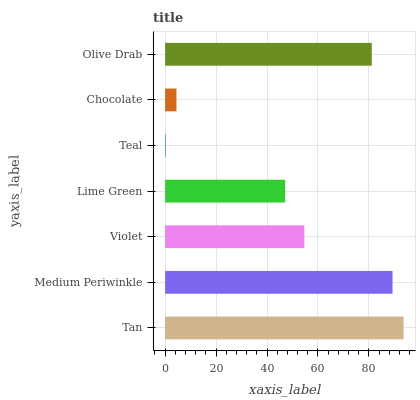Is Teal the minimum?
Answer yes or no. Yes. Is Tan the maximum?
Answer yes or no. Yes. Is Medium Periwinkle the minimum?
Answer yes or no. No. Is Medium Periwinkle the maximum?
Answer yes or no. No. Is Tan greater than Medium Periwinkle?
Answer yes or no. Yes. Is Medium Periwinkle less than Tan?
Answer yes or no. Yes. Is Medium Periwinkle greater than Tan?
Answer yes or no. No. Is Tan less than Medium Periwinkle?
Answer yes or no. No. Is Violet the high median?
Answer yes or no. Yes. Is Violet the low median?
Answer yes or no. Yes. Is Teal the high median?
Answer yes or no. No. Is Medium Periwinkle the low median?
Answer yes or no. No. 